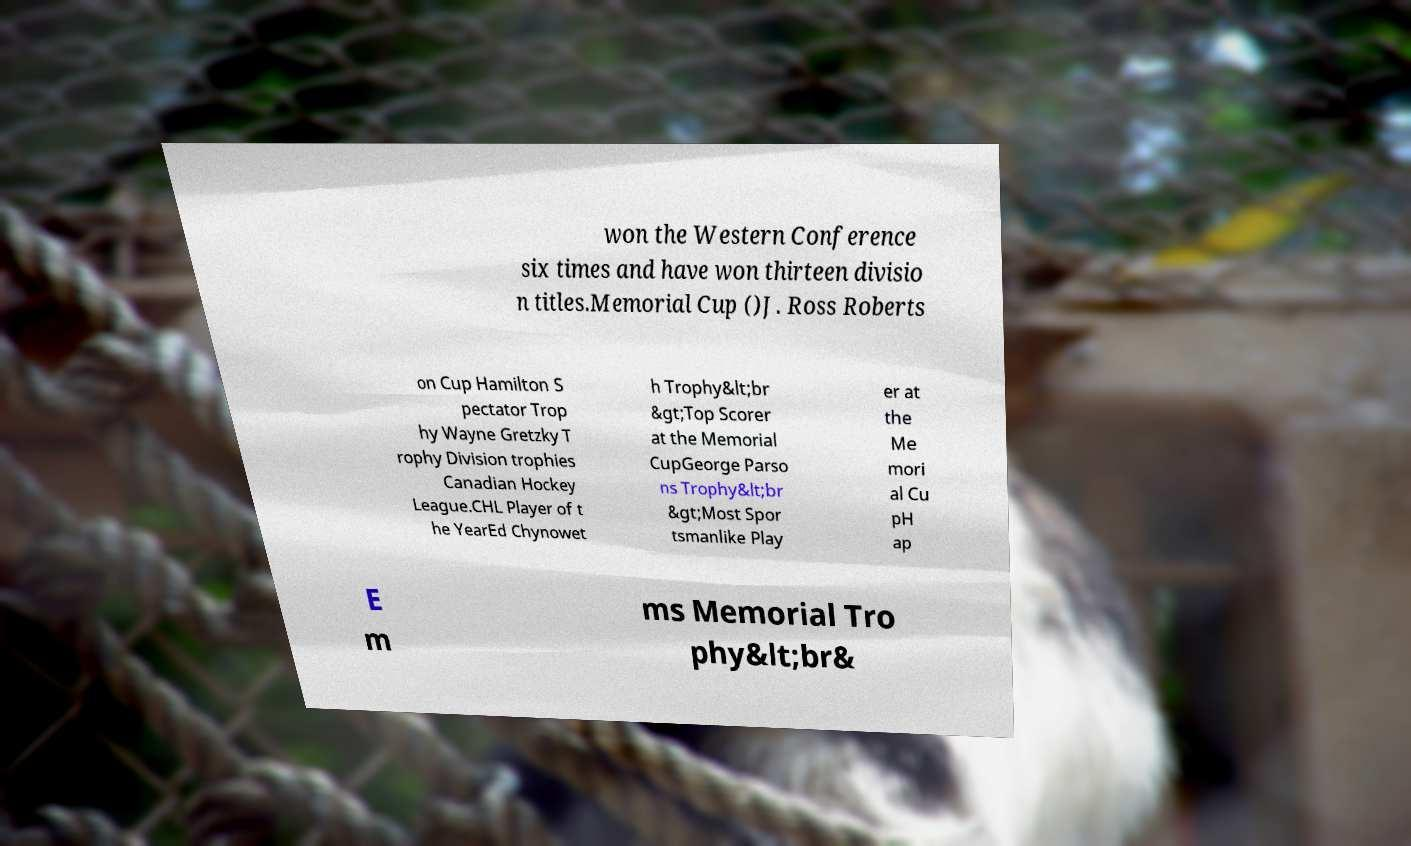There's text embedded in this image that I need extracted. Can you transcribe it verbatim? won the Western Conference six times and have won thirteen divisio n titles.Memorial Cup ()J. Ross Roberts on Cup Hamilton S pectator Trop hy Wayne Gretzky T rophy Division trophies Canadian Hockey League.CHL Player of t he YearEd Chynowet h Trophy&lt;br &gt;Top Scorer at the Memorial CupGeorge Parso ns Trophy&lt;br &gt;Most Spor tsmanlike Play er at the Me mori al Cu pH ap E m ms Memorial Tro phy&lt;br& 